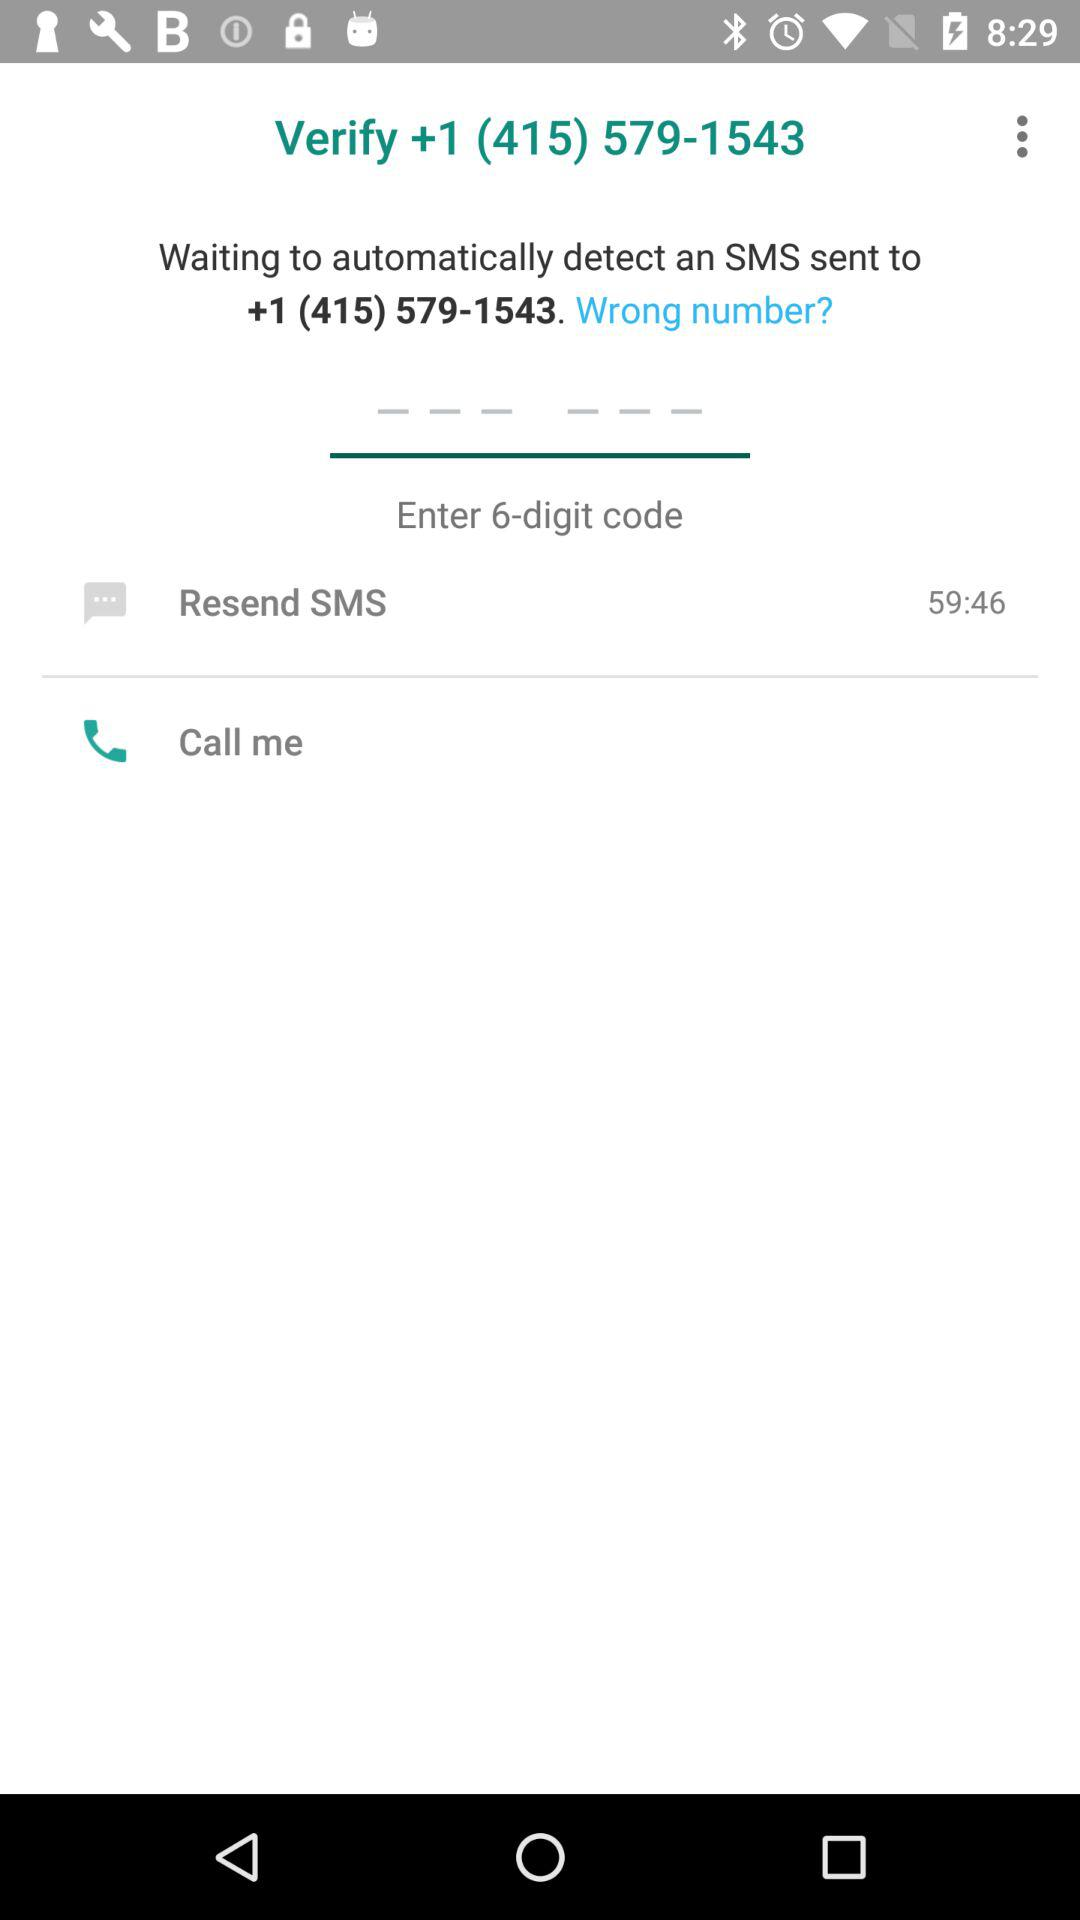How many digits does the code consist of? The code consists of 6 digits. 